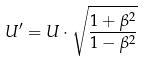<formula> <loc_0><loc_0><loc_500><loc_500>U ^ { \prime } = U \cdot \sqrt { \frac { 1 + \beta ^ { 2 } } { 1 - \beta ^ { 2 } } }</formula> 